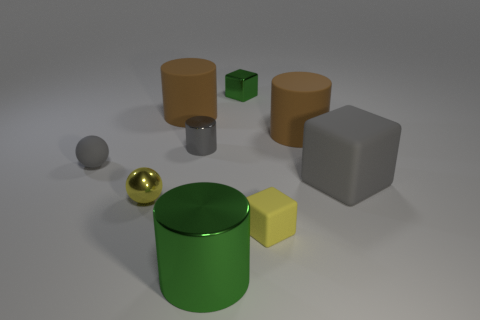What shape is the tiny matte thing that is the same color as the small cylinder?
Offer a terse response. Sphere. Is there a small purple object that has the same material as the green cylinder?
Make the answer very short. No. What is the size of the thing that is the same color as the small shiny ball?
Your response must be concise. Small. How many spheres are either brown rubber things or tiny gray rubber things?
Provide a short and direct response. 1. What size is the green metallic block?
Your answer should be very brief. Small. There is a gray metallic object; what number of tiny metallic spheres are to the left of it?
Your answer should be compact. 1. There is a green object in front of the tiny rubber object in front of the tiny gray ball; what is its size?
Your response must be concise. Large. There is a tiny object behind the gray shiny object; does it have the same shape as the tiny rubber thing on the right side of the tiny gray cylinder?
Give a very brief answer. Yes. The yellow matte thing that is in front of the big brown matte cylinder that is to the right of the tiny metal block is what shape?
Ensure brevity in your answer.  Cube. What size is the shiny thing that is behind the gray matte sphere and in front of the small shiny cube?
Your answer should be very brief. Small. 